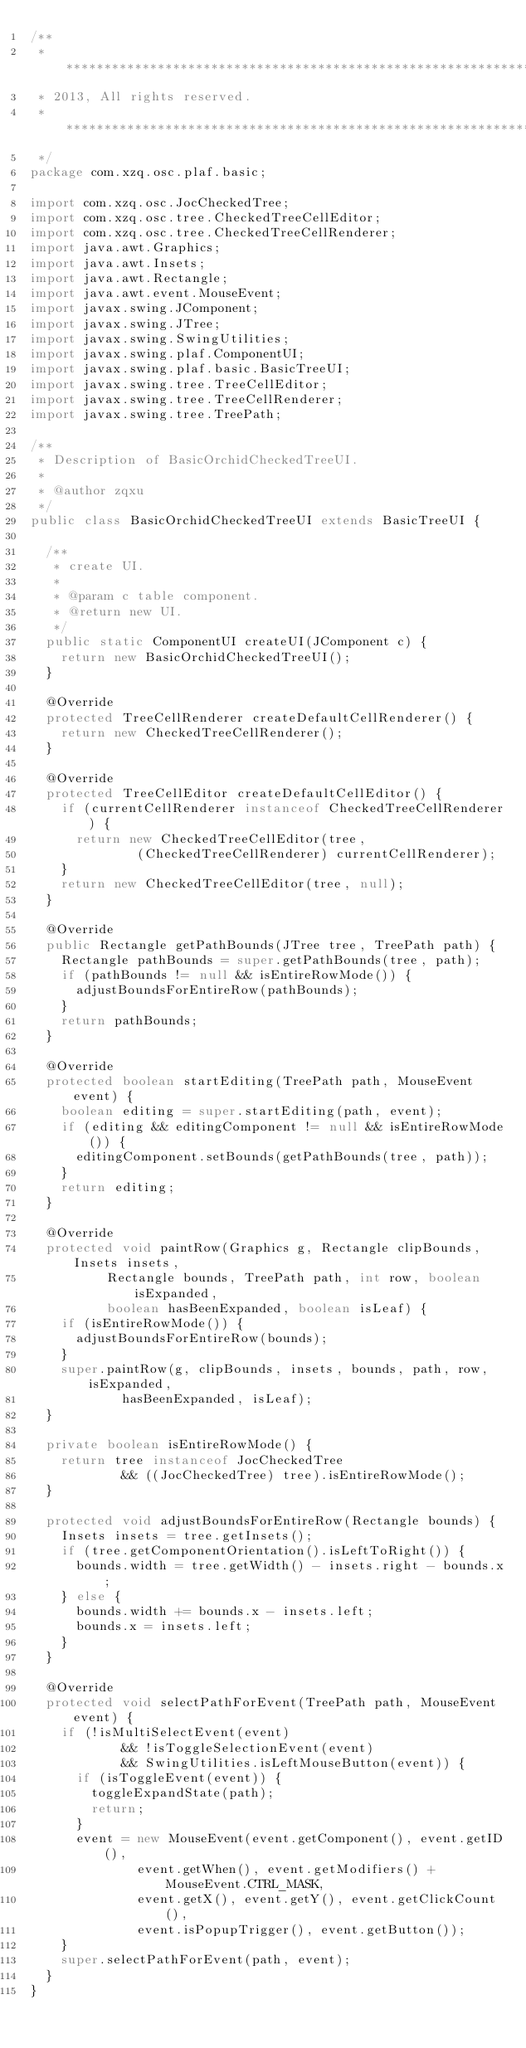Convert code to text. <code><loc_0><loc_0><loc_500><loc_500><_Java_>/**
 * *****************************************************************************
 * 2013, All rights reserved.
 * *****************************************************************************
 */
package com.xzq.osc.plaf.basic;

import com.xzq.osc.JocCheckedTree;
import com.xzq.osc.tree.CheckedTreeCellEditor;
import com.xzq.osc.tree.CheckedTreeCellRenderer;
import java.awt.Graphics;
import java.awt.Insets;
import java.awt.Rectangle;
import java.awt.event.MouseEvent;
import javax.swing.JComponent;
import javax.swing.JTree;
import javax.swing.SwingUtilities;
import javax.swing.plaf.ComponentUI;
import javax.swing.plaf.basic.BasicTreeUI;
import javax.swing.tree.TreeCellEditor;
import javax.swing.tree.TreeCellRenderer;
import javax.swing.tree.TreePath;

/**
 * Description of BasicOrchidCheckedTreeUI.
 *
 * @author zqxu
 */
public class BasicOrchidCheckedTreeUI extends BasicTreeUI {

  /**
   * create UI.
   *
   * @param c table component.
   * @return new UI.
   */
  public static ComponentUI createUI(JComponent c) {
    return new BasicOrchidCheckedTreeUI();
  }

  @Override
  protected TreeCellRenderer createDefaultCellRenderer() {
    return new CheckedTreeCellRenderer();
  }

  @Override
  protected TreeCellEditor createDefaultCellEditor() {
    if (currentCellRenderer instanceof CheckedTreeCellRenderer) {
      return new CheckedTreeCellEditor(tree,
              (CheckedTreeCellRenderer) currentCellRenderer);
    }
    return new CheckedTreeCellEditor(tree, null);
  }

  @Override
  public Rectangle getPathBounds(JTree tree, TreePath path) {
    Rectangle pathBounds = super.getPathBounds(tree, path);
    if (pathBounds != null && isEntireRowMode()) {
      adjustBoundsForEntireRow(pathBounds);
    }
    return pathBounds;
  }

  @Override
  protected boolean startEditing(TreePath path, MouseEvent event) {
    boolean editing = super.startEditing(path, event);
    if (editing && editingComponent != null && isEntireRowMode()) {
      editingComponent.setBounds(getPathBounds(tree, path));
    }
    return editing;
  }

  @Override
  protected void paintRow(Graphics g, Rectangle clipBounds, Insets insets,
          Rectangle bounds, TreePath path, int row, boolean isExpanded,
          boolean hasBeenExpanded, boolean isLeaf) {
    if (isEntireRowMode()) {
      adjustBoundsForEntireRow(bounds);
    }
    super.paintRow(g, clipBounds, insets, bounds, path, row, isExpanded,
            hasBeenExpanded, isLeaf);
  }

  private boolean isEntireRowMode() {
    return tree instanceof JocCheckedTree
            && ((JocCheckedTree) tree).isEntireRowMode();
  }

  protected void adjustBoundsForEntireRow(Rectangle bounds) {
    Insets insets = tree.getInsets();
    if (tree.getComponentOrientation().isLeftToRight()) {
      bounds.width = tree.getWidth() - insets.right - bounds.x;
    } else {
      bounds.width += bounds.x - insets.left;
      bounds.x = insets.left;
    }
  }

  @Override
  protected void selectPathForEvent(TreePath path, MouseEvent event) {
    if (!isMultiSelectEvent(event)
            && !isToggleSelectionEvent(event)
            && SwingUtilities.isLeftMouseButton(event)) {
      if (isToggleEvent(event)) {
        toggleExpandState(path);
        return;
      }
      event = new MouseEvent(event.getComponent(), event.getID(),
              event.getWhen(), event.getModifiers() + MouseEvent.CTRL_MASK,
              event.getX(), event.getY(), event.getClickCount(),
              event.isPopupTrigger(), event.getButton());
    }
    super.selectPathForEvent(path, event);
  }
}
</code> 